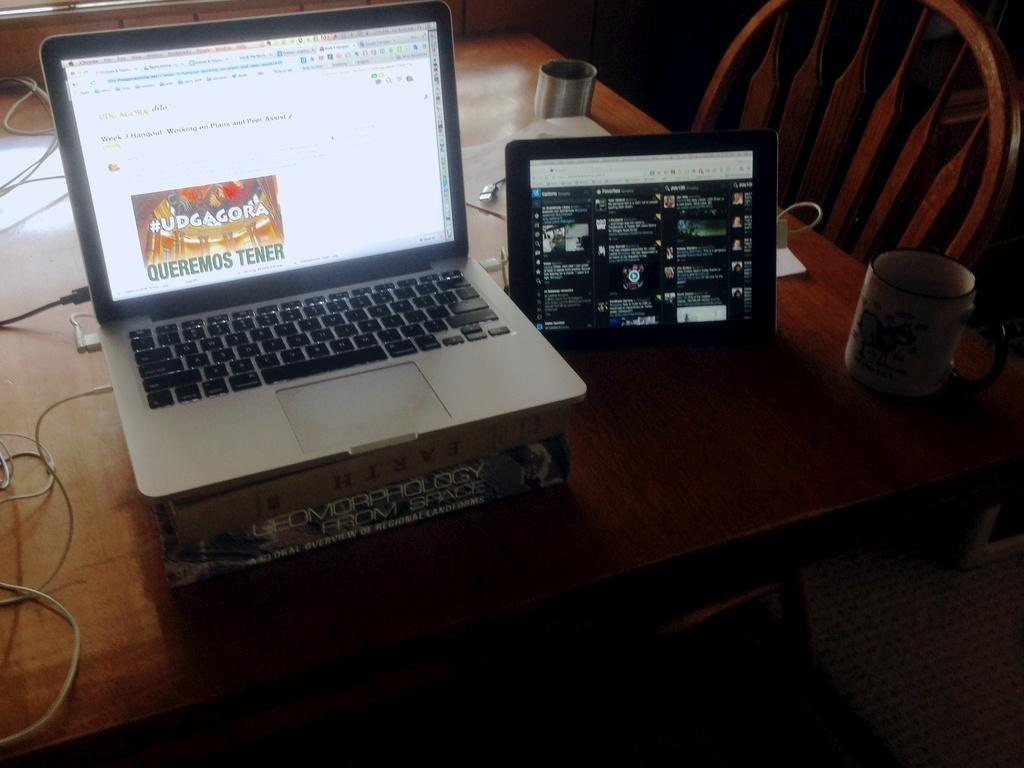What is on the table in the image? There is a box, a laptop, an iPad, a cup, and cables on the table in the image. What electronic devices are visible in the image? The laptop and iPad are the electronic devices visible in the image. What might be used for holding liquids in the image? There is a cup on the table that could be used for holding liquids. What is the purpose of the cables in the image? The cables in the image are likely used to connect and power the electronic devices. What piece of furniture is beside the table in the image? There is a chair beside the table in the image. What type of cord is wrapped around the love in the image? There is no mention of love or a cord in the image; it primarily features a table with various objects on it. 